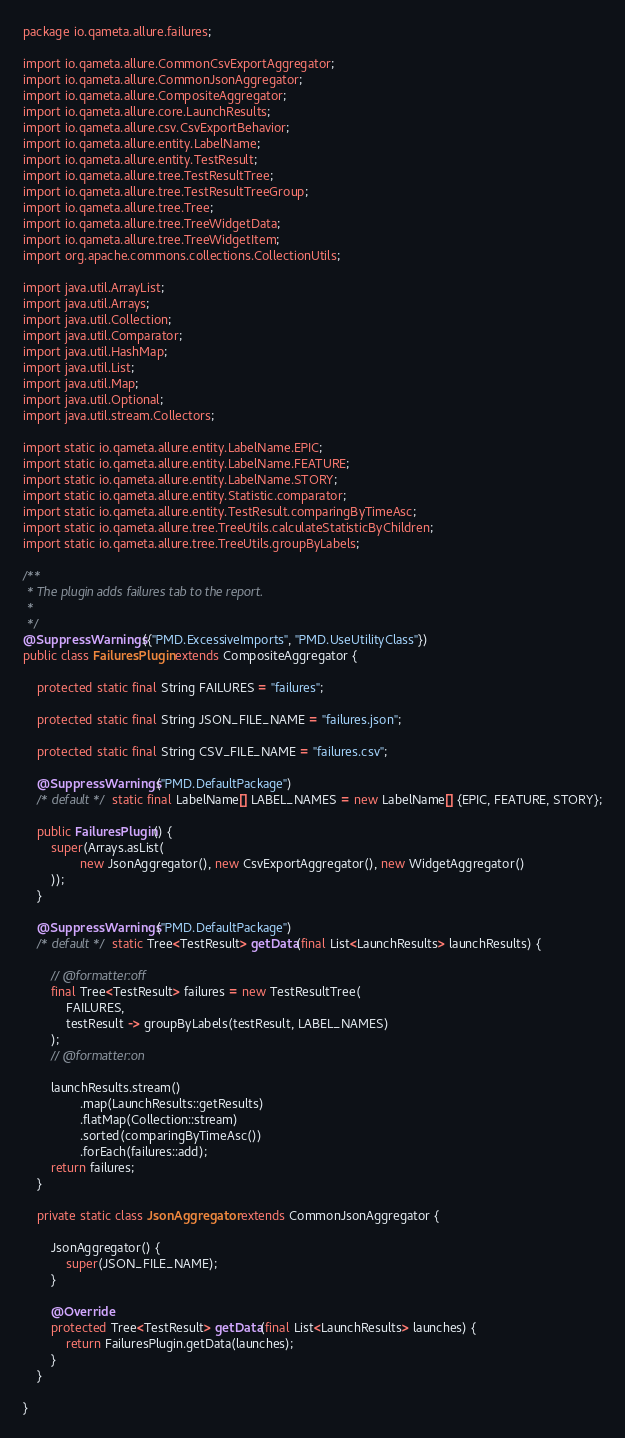<code> <loc_0><loc_0><loc_500><loc_500><_Java_>package io.qameta.allure.failures;

import io.qameta.allure.CommonCsvExportAggregator;
import io.qameta.allure.CommonJsonAggregator;
import io.qameta.allure.CompositeAggregator;
import io.qameta.allure.core.LaunchResults;
import io.qameta.allure.csv.CsvExportBehavior;
import io.qameta.allure.entity.LabelName;
import io.qameta.allure.entity.TestResult;
import io.qameta.allure.tree.TestResultTree;
import io.qameta.allure.tree.TestResultTreeGroup;
import io.qameta.allure.tree.Tree;
import io.qameta.allure.tree.TreeWidgetData;
import io.qameta.allure.tree.TreeWidgetItem;
import org.apache.commons.collections.CollectionUtils;

import java.util.ArrayList;
import java.util.Arrays;
import java.util.Collection;
import java.util.Comparator;
import java.util.HashMap;
import java.util.List;
import java.util.Map;
import java.util.Optional;
import java.util.stream.Collectors;

import static io.qameta.allure.entity.LabelName.EPIC;
import static io.qameta.allure.entity.LabelName.FEATURE;
import static io.qameta.allure.entity.LabelName.STORY;
import static io.qameta.allure.entity.Statistic.comparator;
import static io.qameta.allure.entity.TestResult.comparingByTimeAsc;
import static io.qameta.allure.tree.TreeUtils.calculateStatisticByChildren;
import static io.qameta.allure.tree.TreeUtils.groupByLabels;

/**
 * The plugin adds failures tab to the report.
 *
 */
@SuppressWarnings({"PMD.ExcessiveImports", "PMD.UseUtilityClass"})
public class FailuresPlugin extends CompositeAggregator {

    protected static final String FAILURES = "failures";

    protected static final String JSON_FILE_NAME = "failures.json";

    protected static final String CSV_FILE_NAME = "failures.csv";

    @SuppressWarnings("PMD.DefaultPackage")
    /* default */ static final LabelName[] LABEL_NAMES = new LabelName[] {EPIC, FEATURE, STORY};

    public FailuresPlugin() {
        super(Arrays.asList(
                new JsonAggregator(), new CsvExportAggregator(), new WidgetAggregator()
        ));
    }

    @SuppressWarnings("PMD.DefaultPackage")
    /* default */ static Tree<TestResult> getData(final List<LaunchResults> launchResults) {

        // @formatter:off
        final Tree<TestResult> failures = new TestResultTree(
            FAILURES,
            testResult -> groupByLabels(testResult, LABEL_NAMES)
        );
        // @formatter:on

        launchResults.stream()
                .map(LaunchResults::getResults)
                .flatMap(Collection::stream)
                .sorted(comparingByTimeAsc())
                .forEach(failures::add);
        return failures;
    }

    private static class JsonAggregator extends CommonJsonAggregator {

        JsonAggregator() {
            super(JSON_FILE_NAME);
        }

        @Override
        protected Tree<TestResult> getData(final List<LaunchResults> launches) {
            return FailuresPlugin.getData(launches);
        }
    }

}
</code> 